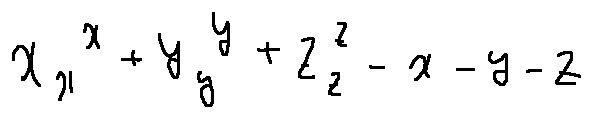<formula> <loc_0><loc_0><loc_500><loc_500>x _ { x } ^ { x } + y _ { y } ^ { y } + z _ { z } ^ { z } - x - y - z</formula> 